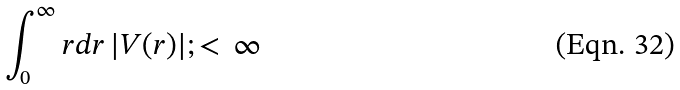<formula> <loc_0><loc_0><loc_500><loc_500>\int ^ { \infty } _ { 0 } r d r \, | V ( r ) | ; < \, \infty</formula> 